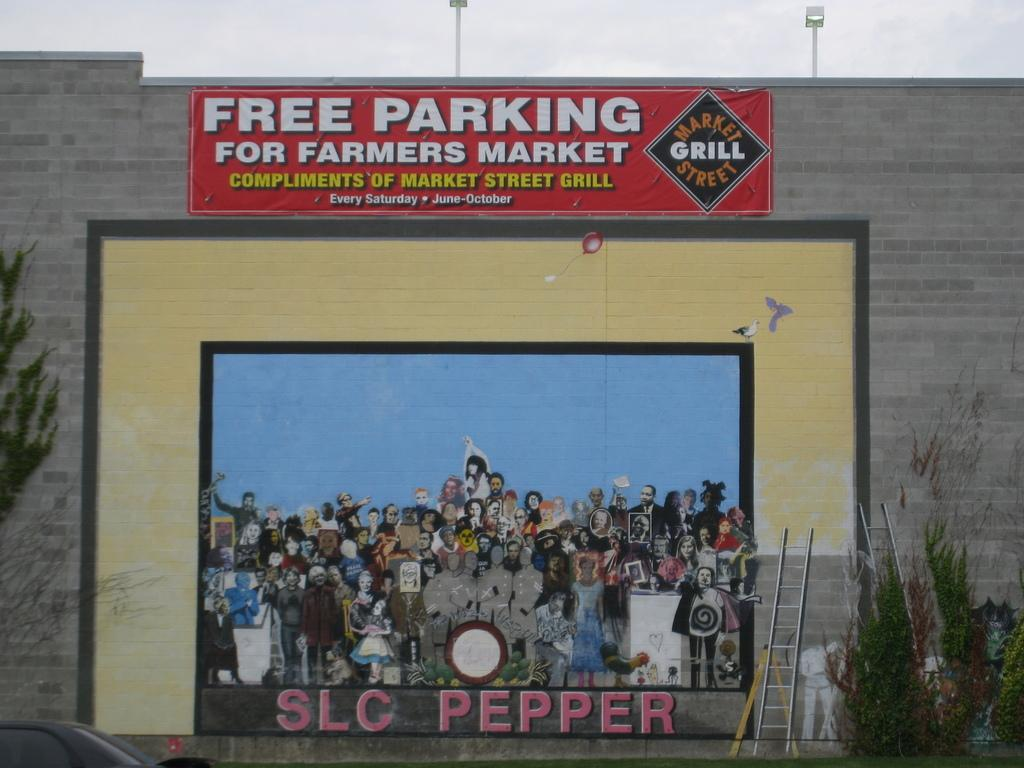<image>
Describe the image concisely. A cement wall with a sign designating free parking for the farmers market. 